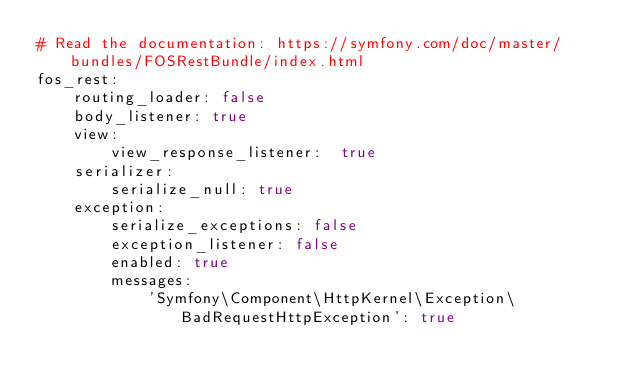Convert code to text. <code><loc_0><loc_0><loc_500><loc_500><_YAML_># Read the documentation: https://symfony.com/doc/master/bundles/FOSRestBundle/index.html
fos_rest:
    routing_loader: false
    body_listener: true
    view:
        view_response_listener:  true
    serializer:
        serialize_null: true
    exception:
        serialize_exceptions: false
        exception_listener: false
        enabled: true
        messages:
            'Symfony\Component\HttpKernel\Exception\BadRequestHttpException': true
</code> 